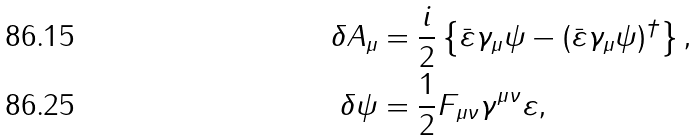Convert formula to latex. <formula><loc_0><loc_0><loc_500><loc_500>\delta A _ { \mu } & = \frac { i } { 2 } \left \{ \bar { \varepsilon } \gamma _ { \mu } \psi - ( \bar { \varepsilon } \gamma _ { \mu } \psi ) ^ { \dag } \right \} , \\ \delta \psi & = \frac { 1 } { 2 } F _ { \mu \nu } \gamma ^ { \mu \nu } \varepsilon ,</formula> 